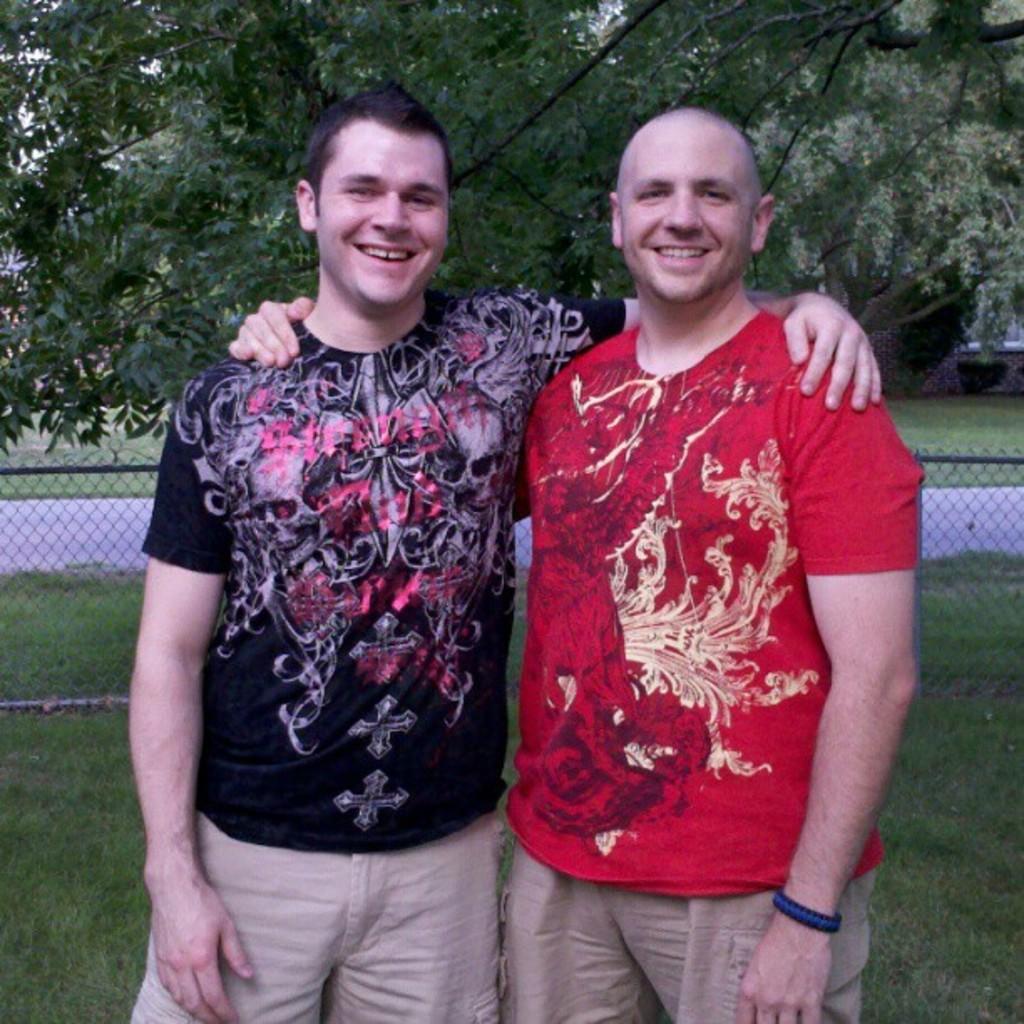Could you give a brief overview of what you see in this image? In the foreground of the picture there are two men standing, they are smiling. Behind them there are grass, railing, trees and a path. 